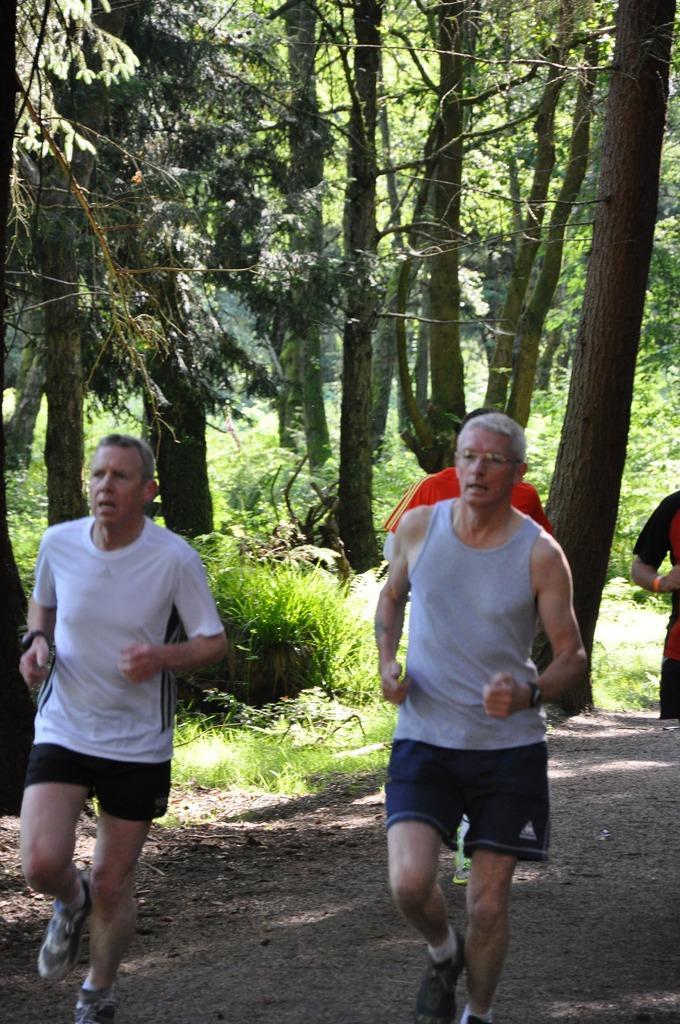How would you summarize this image in a sentence or two? In this image I can see there are few persons walking on the road, back side of them there are some trees and bushes visible. 